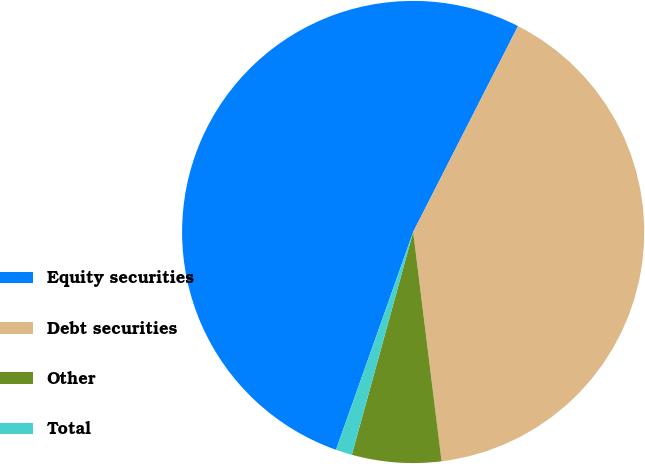Convert chart to OTSL. <chart><loc_0><loc_0><loc_500><loc_500><pie_chart><fcel>Equity securities<fcel>Debt securities<fcel>Other<fcel>Total<nl><fcel>52.08%<fcel>40.54%<fcel>6.24%<fcel>1.14%<nl></chart> 